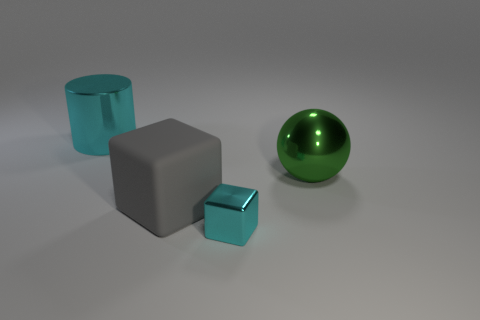Subtract all cyan cubes. How many cubes are left? 1 Add 4 big gray rubber cubes. How many objects exist? 8 Subtract all cylinders. How many objects are left? 3 Subtract all small green blocks. Subtract all metal cylinders. How many objects are left? 3 Add 1 cylinders. How many cylinders are left? 2 Add 4 small red metallic cubes. How many small red metallic cubes exist? 4 Subtract 0 green cubes. How many objects are left? 4 Subtract 1 cylinders. How many cylinders are left? 0 Subtract all purple cubes. Subtract all brown cylinders. How many cubes are left? 2 Subtract all cyan cylinders. How many cyan cubes are left? 1 